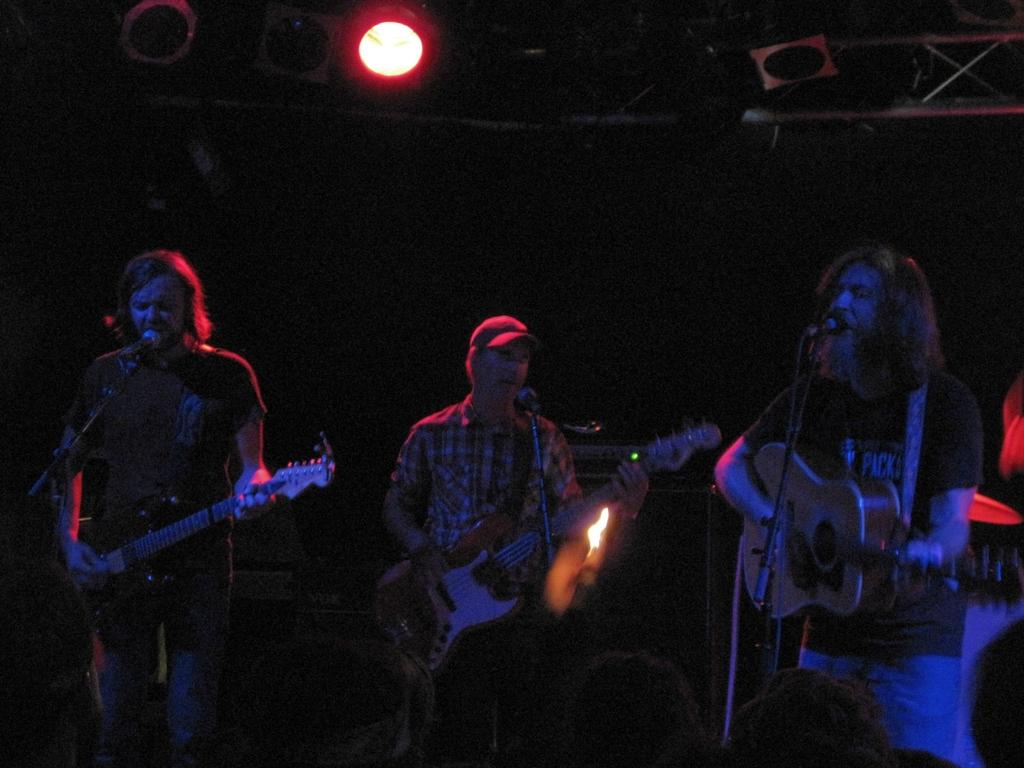What is the man in the image doing? The man is playing a guitar in the image. What object is present that is typically used for amplifying sound? There is a microphone in the image. What can be seen in the image that might indicate a performance or event? There are lights visible in the image. What type of coil is visible on the man's bed in the image? There is no bed or coil present in the image; it features a man playing a guitar with a microphone and lights. 